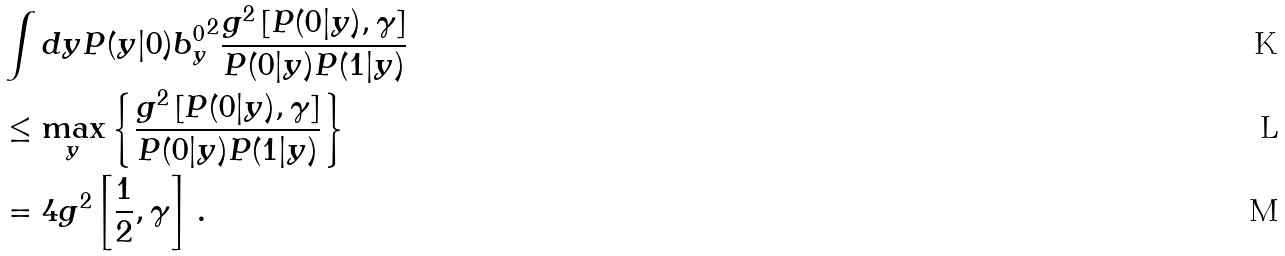Convert formula to latex. <formula><loc_0><loc_0><loc_500><loc_500>& \int d y P ( y | 0 ) { b _ { y } ^ { 0 } } ^ { 2 } \frac { g ^ { 2 } \left [ P ( 0 | y ) , \gamma \right ] } { P ( 0 | y ) P ( 1 | y ) } \\ & \leq \max _ { y } \left \{ \frac { g ^ { 2 } \left [ P ( 0 | y ) , \gamma \right ] } { P ( 0 | y ) P ( 1 | y ) } \right \} \\ & = 4 g ^ { 2 } \left [ \frac { 1 } { 2 } , \gamma \right ] \, .</formula> 